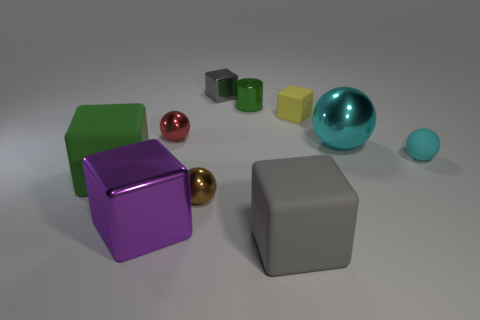Subtract all tiny metal cubes. How many cubes are left? 4 Subtract all green blocks. How many blocks are left? 4 Subtract all cyan cylinders. Subtract all gray balls. How many cylinders are left? 1 Subtract all cylinders. How many objects are left? 9 Add 2 shiny cylinders. How many shiny cylinders exist? 3 Subtract 0 red cylinders. How many objects are left? 10 Subtract all gray matte things. Subtract all large green cylinders. How many objects are left? 9 Add 3 metallic objects. How many metallic objects are left? 9 